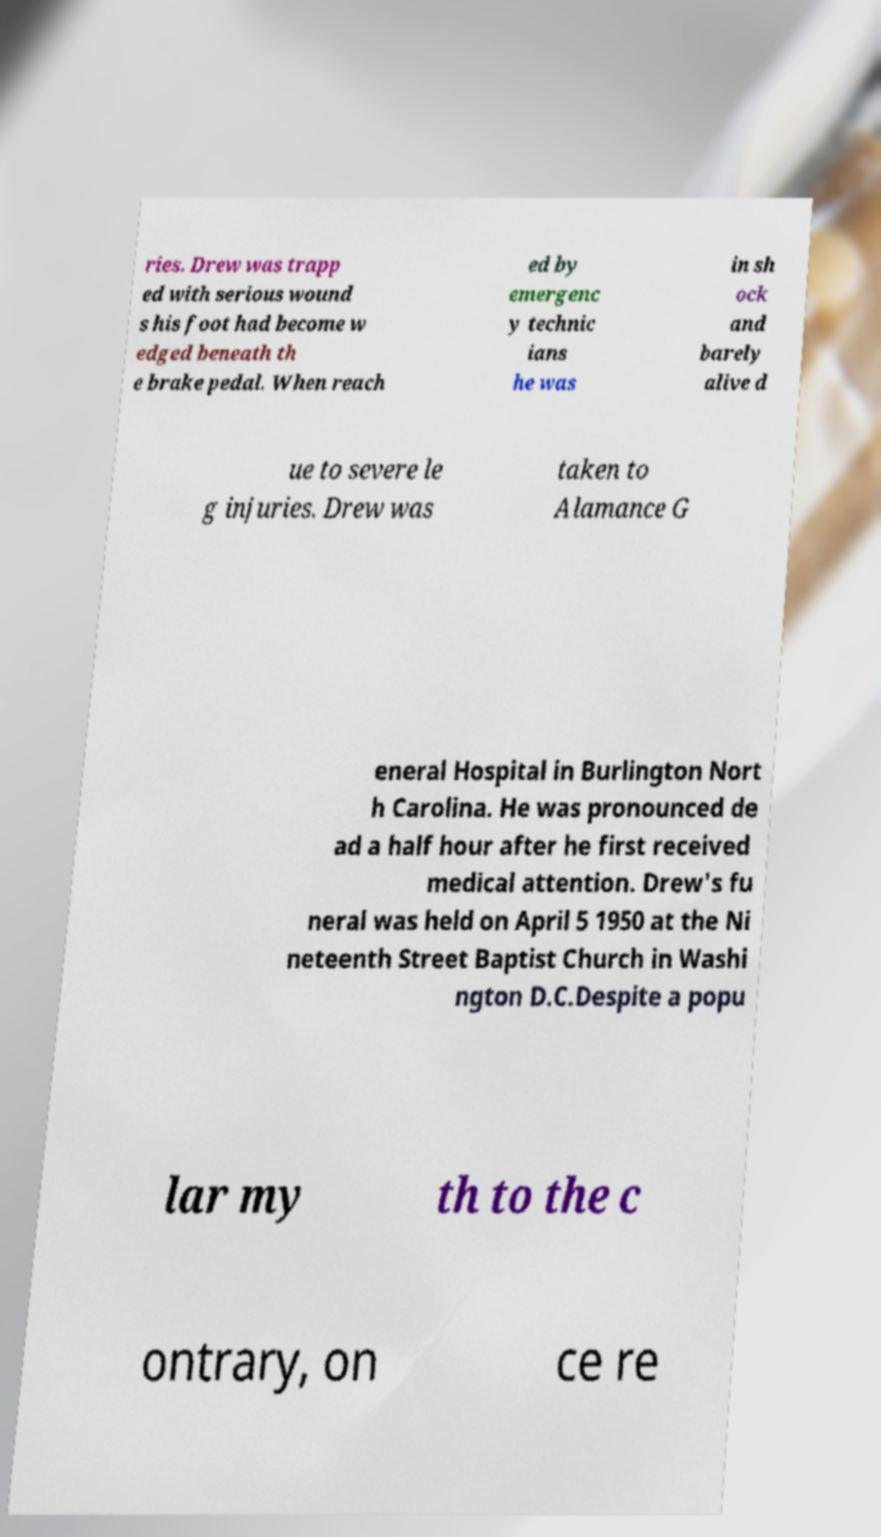For documentation purposes, I need the text within this image transcribed. Could you provide that? ries. Drew was trapp ed with serious wound s his foot had become w edged beneath th e brake pedal. When reach ed by emergenc y technic ians he was in sh ock and barely alive d ue to severe le g injuries. Drew was taken to Alamance G eneral Hospital in Burlington Nort h Carolina. He was pronounced de ad a half hour after he first received medical attention. Drew's fu neral was held on April 5 1950 at the Ni neteenth Street Baptist Church in Washi ngton D.C.Despite a popu lar my th to the c ontrary, on ce re 